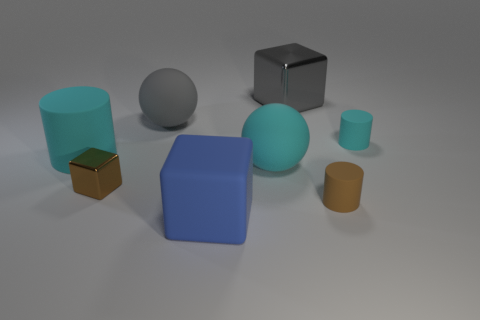There is a large gray thing that is the same shape as the blue matte object; what is its material? The large gray object resembling the shape of the blue matte object appears to be made of a material with metallic properties, likely steel or aluminum, given its reflective surface and color characteristic of such metals. 